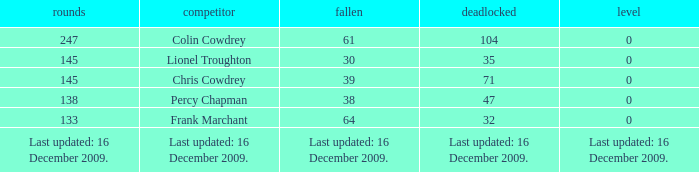I want to know the tie for drawn of 47 0.0. 